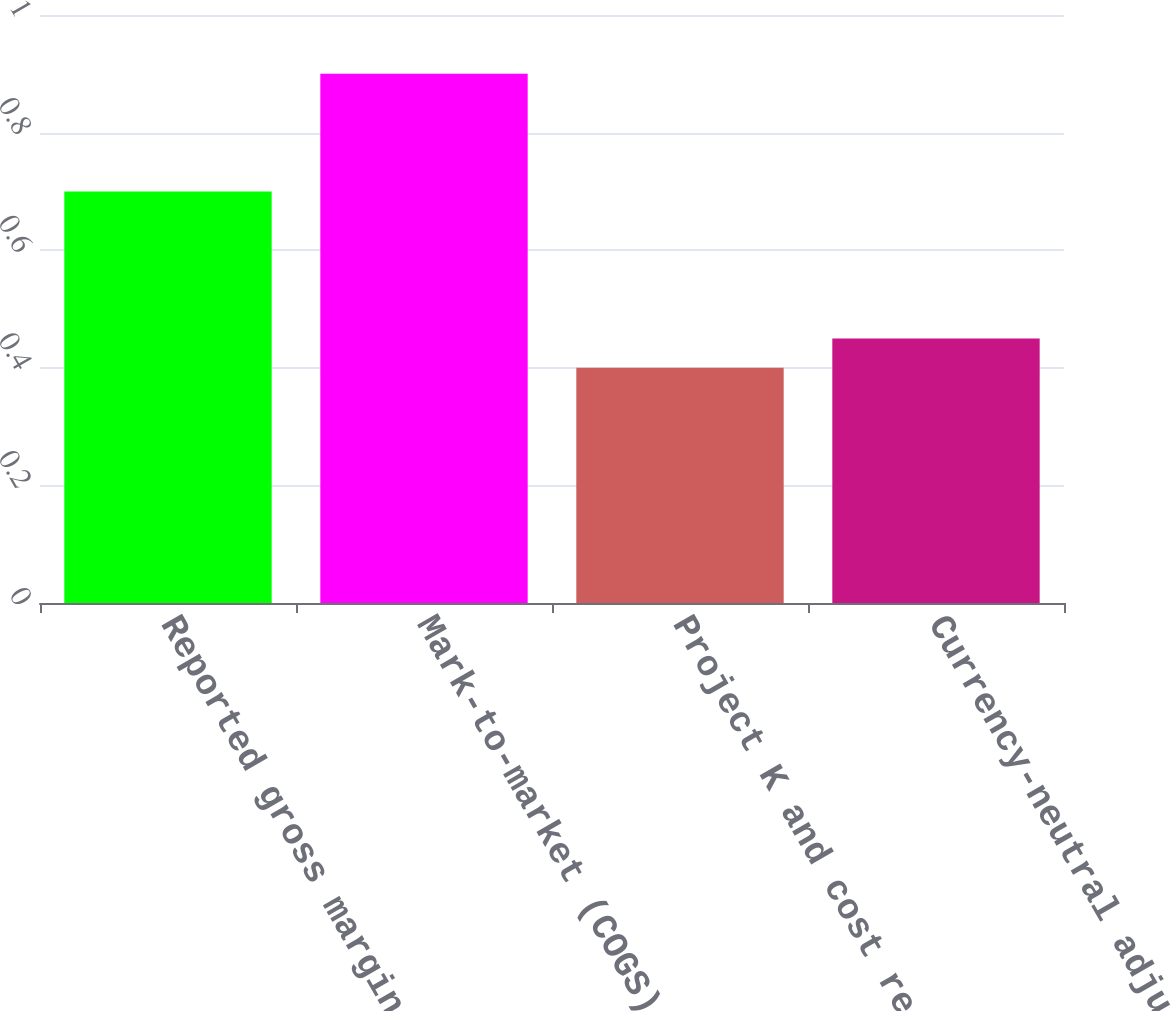Convert chart. <chart><loc_0><loc_0><loc_500><loc_500><bar_chart><fcel>Reported gross margin (a)<fcel>Mark-to-market (COGS)<fcel>Project K and cost reduction<fcel>Currency-neutral adjusted<nl><fcel>0.7<fcel>0.9<fcel>0.4<fcel>0.45<nl></chart> 